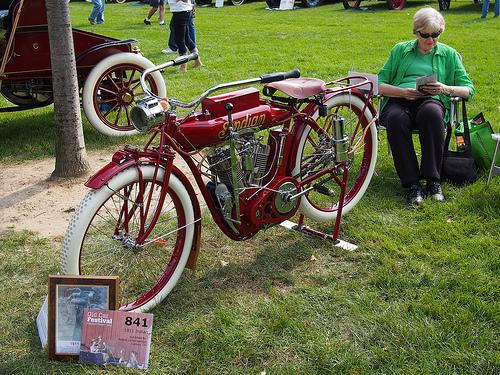What is the color and type of the main vehicle in the image? It is an antique red motorcycle. What is the sentiment depicted by the main object in the image, and why? A nostalgic sentiment is depicted by the antique red motorcycle, indicating a connection to the past. What object is placed at the top-left corner of the image, and what is its size? Part of a very old car is placed at the top-left corner with size Width:170, Height:170. Describe the woman in the image in terms of her clothing and accessories. The woman is wearing a green shirt, a pair of sunglasses, and is possibly reading. How many patches of green grass are present in the image? There are 9 patches of green grass. 